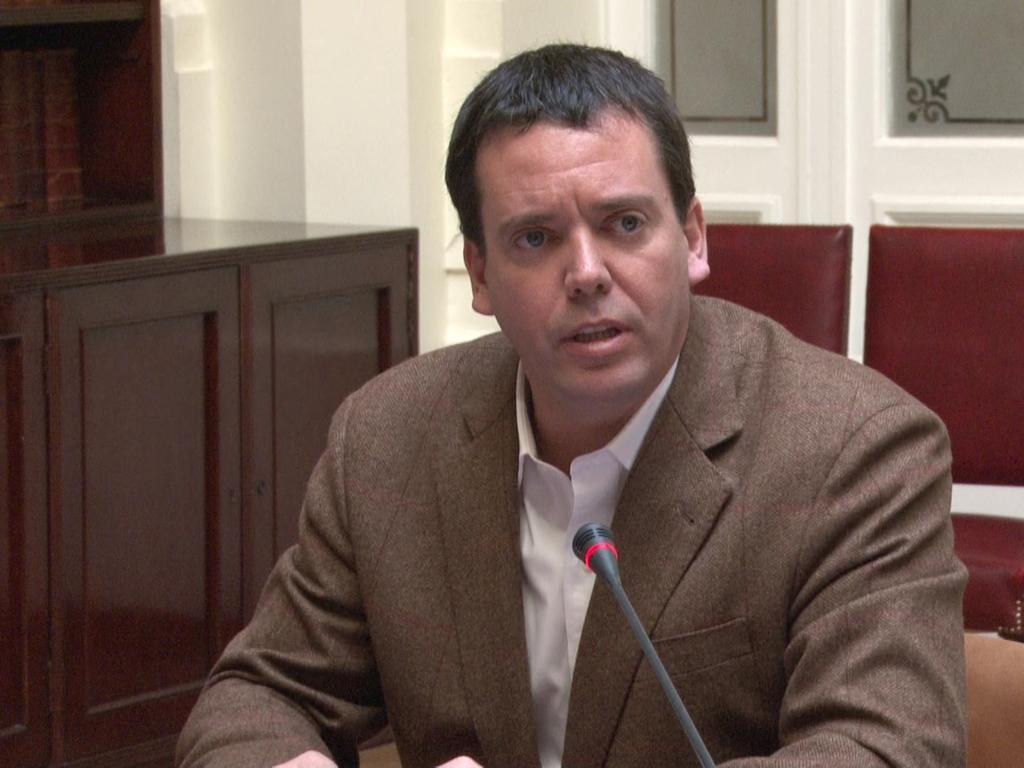Describe this image in one or two sentences. In this picture there is a man and we can see a microphone. In the background of the image we can see cupboards, wall and chairs. 